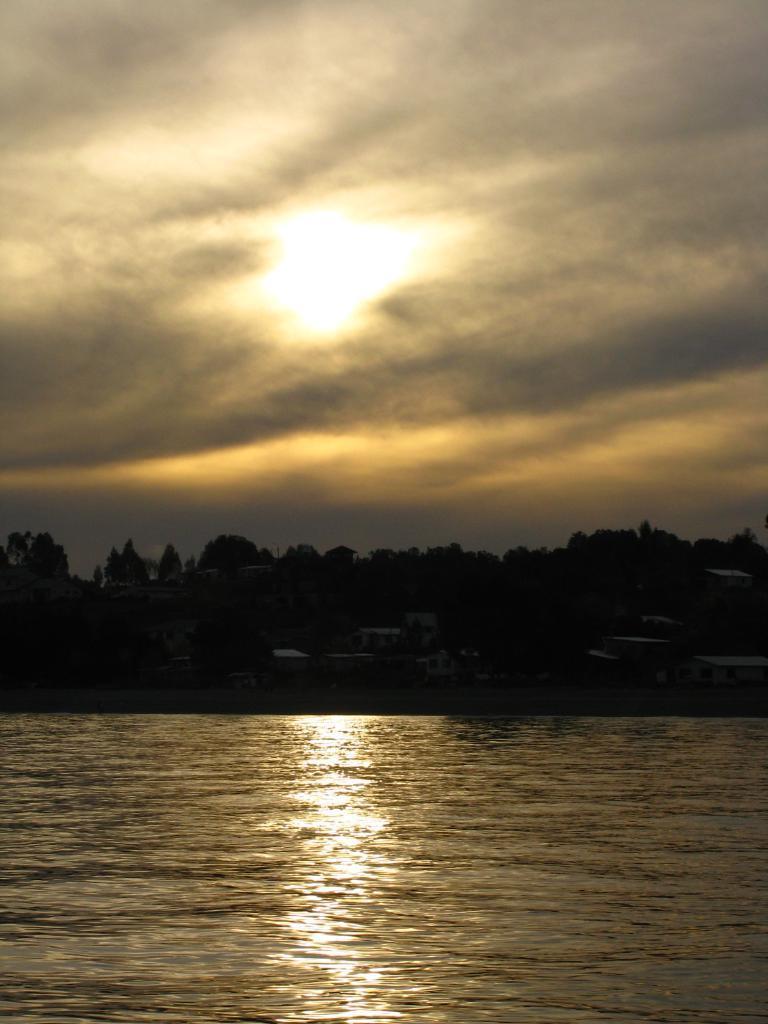In one or two sentences, can you explain what this image depicts? In this image I can see water in the front. In the background I can see number of trees, few buildings, clouds, the sky and the sun. 